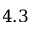Convert formula to latex. <formula><loc_0><loc_0><loc_500><loc_500>4 . 3</formula> 